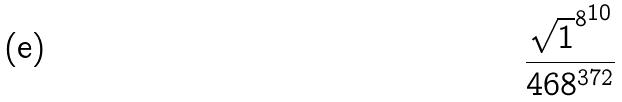Convert formula to latex. <formula><loc_0><loc_0><loc_500><loc_500>\frac { { \sqrt { 1 } ^ { 8 } } ^ { 1 0 } } { 4 6 8 ^ { 3 7 2 } }</formula> 